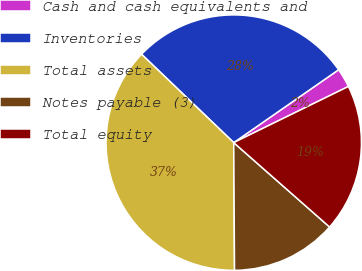Convert chart. <chart><loc_0><loc_0><loc_500><loc_500><pie_chart><fcel>Cash and cash equivalents and<fcel>Inventories<fcel>Total assets<fcel>Notes payable (3)<fcel>Total equity<nl><fcel>2.42%<fcel>28.17%<fcel>37.26%<fcel>13.41%<fcel>18.73%<nl></chart> 